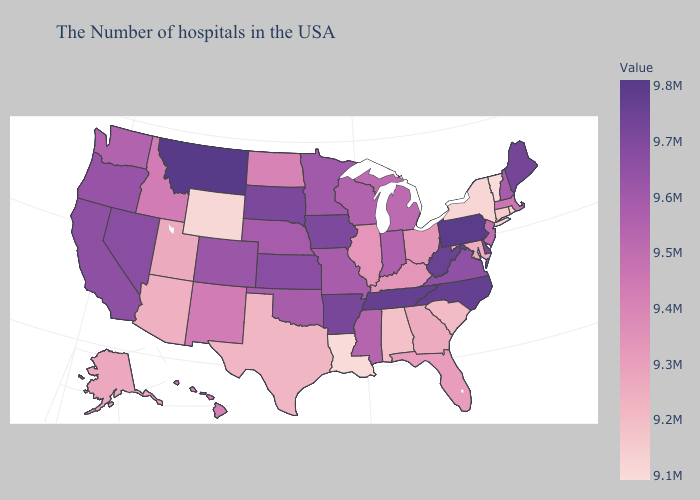Which states hav the highest value in the Northeast?
Be succinct. Pennsylvania. Does the map have missing data?
Quick response, please. No. Is the legend a continuous bar?
Be succinct. Yes. Among the states that border New Mexico , which have the highest value?
Give a very brief answer. Colorado. Among the states that border Kansas , which have the highest value?
Answer briefly. Colorado. 